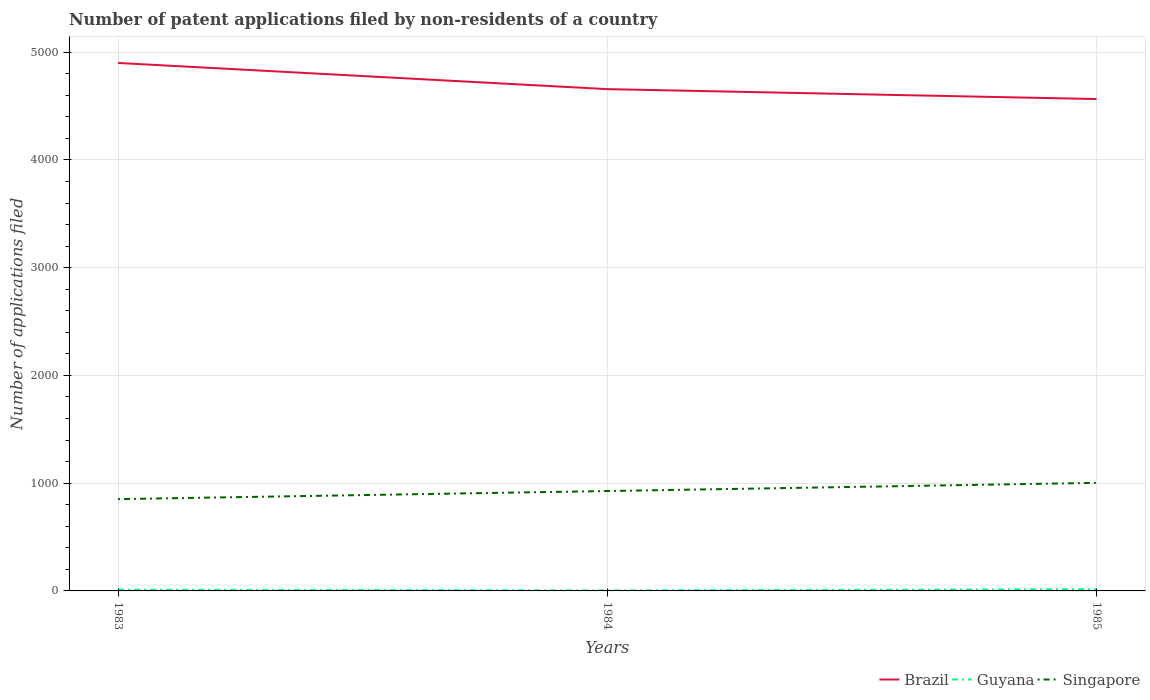Is the number of lines equal to the number of legend labels?
Provide a short and direct response. Yes. In which year was the number of applications filed in Brazil maximum?
Your response must be concise. 1985. What is the total number of applications filed in Guyana in the graph?
Offer a terse response. -4. What is the difference between the highest and the second highest number of applications filed in Brazil?
Offer a terse response. 335. What is the difference between the highest and the lowest number of applications filed in Guyana?
Offer a very short reply. 2. Is the number of applications filed in Guyana strictly greater than the number of applications filed in Singapore over the years?
Ensure brevity in your answer.  Yes. How many lines are there?
Provide a short and direct response. 3. How many years are there in the graph?
Give a very brief answer. 3. Does the graph contain any zero values?
Ensure brevity in your answer.  No. Where does the legend appear in the graph?
Your response must be concise. Bottom right. What is the title of the graph?
Offer a terse response. Number of patent applications filed by non-residents of a country. Does "Macedonia" appear as one of the legend labels in the graph?
Your answer should be compact. No. What is the label or title of the X-axis?
Provide a succinct answer. Years. What is the label or title of the Y-axis?
Keep it short and to the point. Number of applications filed. What is the Number of applications filed of Brazil in 1983?
Provide a succinct answer. 4900. What is the Number of applications filed in Singapore in 1983?
Your answer should be very brief. 852. What is the Number of applications filed of Brazil in 1984?
Provide a succinct answer. 4657. What is the Number of applications filed in Singapore in 1984?
Offer a very short reply. 927. What is the Number of applications filed of Brazil in 1985?
Give a very brief answer. 4565. What is the Number of applications filed of Singapore in 1985?
Make the answer very short. 1003. Across all years, what is the maximum Number of applications filed of Brazil?
Offer a terse response. 4900. Across all years, what is the maximum Number of applications filed in Guyana?
Provide a short and direct response. 16. Across all years, what is the maximum Number of applications filed of Singapore?
Provide a succinct answer. 1003. Across all years, what is the minimum Number of applications filed in Brazil?
Offer a terse response. 4565. Across all years, what is the minimum Number of applications filed of Singapore?
Offer a very short reply. 852. What is the total Number of applications filed in Brazil in the graph?
Offer a terse response. 1.41e+04. What is the total Number of applications filed of Singapore in the graph?
Ensure brevity in your answer.  2782. What is the difference between the Number of applications filed of Brazil in 1983 and that in 1984?
Offer a terse response. 243. What is the difference between the Number of applications filed of Guyana in 1983 and that in 1984?
Your answer should be very brief. 7. What is the difference between the Number of applications filed in Singapore in 1983 and that in 1984?
Offer a very short reply. -75. What is the difference between the Number of applications filed in Brazil in 1983 and that in 1985?
Provide a short and direct response. 335. What is the difference between the Number of applications filed in Singapore in 1983 and that in 1985?
Provide a succinct answer. -151. What is the difference between the Number of applications filed of Brazil in 1984 and that in 1985?
Give a very brief answer. 92. What is the difference between the Number of applications filed in Singapore in 1984 and that in 1985?
Make the answer very short. -76. What is the difference between the Number of applications filed in Brazil in 1983 and the Number of applications filed in Guyana in 1984?
Provide a short and direct response. 4895. What is the difference between the Number of applications filed in Brazil in 1983 and the Number of applications filed in Singapore in 1984?
Make the answer very short. 3973. What is the difference between the Number of applications filed in Guyana in 1983 and the Number of applications filed in Singapore in 1984?
Offer a very short reply. -915. What is the difference between the Number of applications filed in Brazil in 1983 and the Number of applications filed in Guyana in 1985?
Your response must be concise. 4884. What is the difference between the Number of applications filed in Brazil in 1983 and the Number of applications filed in Singapore in 1985?
Provide a succinct answer. 3897. What is the difference between the Number of applications filed of Guyana in 1983 and the Number of applications filed of Singapore in 1985?
Keep it short and to the point. -991. What is the difference between the Number of applications filed of Brazil in 1984 and the Number of applications filed of Guyana in 1985?
Give a very brief answer. 4641. What is the difference between the Number of applications filed of Brazil in 1984 and the Number of applications filed of Singapore in 1985?
Provide a short and direct response. 3654. What is the difference between the Number of applications filed in Guyana in 1984 and the Number of applications filed in Singapore in 1985?
Make the answer very short. -998. What is the average Number of applications filed in Brazil per year?
Your answer should be very brief. 4707.33. What is the average Number of applications filed in Guyana per year?
Ensure brevity in your answer.  11. What is the average Number of applications filed of Singapore per year?
Offer a terse response. 927.33. In the year 1983, what is the difference between the Number of applications filed of Brazil and Number of applications filed of Guyana?
Keep it short and to the point. 4888. In the year 1983, what is the difference between the Number of applications filed of Brazil and Number of applications filed of Singapore?
Ensure brevity in your answer.  4048. In the year 1983, what is the difference between the Number of applications filed in Guyana and Number of applications filed in Singapore?
Offer a terse response. -840. In the year 1984, what is the difference between the Number of applications filed of Brazil and Number of applications filed of Guyana?
Ensure brevity in your answer.  4652. In the year 1984, what is the difference between the Number of applications filed in Brazil and Number of applications filed in Singapore?
Ensure brevity in your answer.  3730. In the year 1984, what is the difference between the Number of applications filed of Guyana and Number of applications filed of Singapore?
Your answer should be very brief. -922. In the year 1985, what is the difference between the Number of applications filed in Brazil and Number of applications filed in Guyana?
Offer a very short reply. 4549. In the year 1985, what is the difference between the Number of applications filed in Brazil and Number of applications filed in Singapore?
Ensure brevity in your answer.  3562. In the year 1985, what is the difference between the Number of applications filed of Guyana and Number of applications filed of Singapore?
Your answer should be very brief. -987. What is the ratio of the Number of applications filed in Brazil in 1983 to that in 1984?
Give a very brief answer. 1.05. What is the ratio of the Number of applications filed of Guyana in 1983 to that in 1984?
Your answer should be compact. 2.4. What is the ratio of the Number of applications filed in Singapore in 1983 to that in 1984?
Ensure brevity in your answer.  0.92. What is the ratio of the Number of applications filed in Brazil in 1983 to that in 1985?
Your answer should be compact. 1.07. What is the ratio of the Number of applications filed in Guyana in 1983 to that in 1985?
Offer a terse response. 0.75. What is the ratio of the Number of applications filed of Singapore in 1983 to that in 1985?
Keep it short and to the point. 0.85. What is the ratio of the Number of applications filed in Brazil in 1984 to that in 1985?
Provide a succinct answer. 1.02. What is the ratio of the Number of applications filed in Guyana in 1984 to that in 1985?
Your response must be concise. 0.31. What is the ratio of the Number of applications filed in Singapore in 1984 to that in 1985?
Your answer should be very brief. 0.92. What is the difference between the highest and the second highest Number of applications filed of Brazil?
Provide a succinct answer. 243. What is the difference between the highest and the second highest Number of applications filed in Singapore?
Offer a terse response. 76. What is the difference between the highest and the lowest Number of applications filed in Brazil?
Give a very brief answer. 335. What is the difference between the highest and the lowest Number of applications filed of Guyana?
Provide a short and direct response. 11. What is the difference between the highest and the lowest Number of applications filed of Singapore?
Provide a succinct answer. 151. 